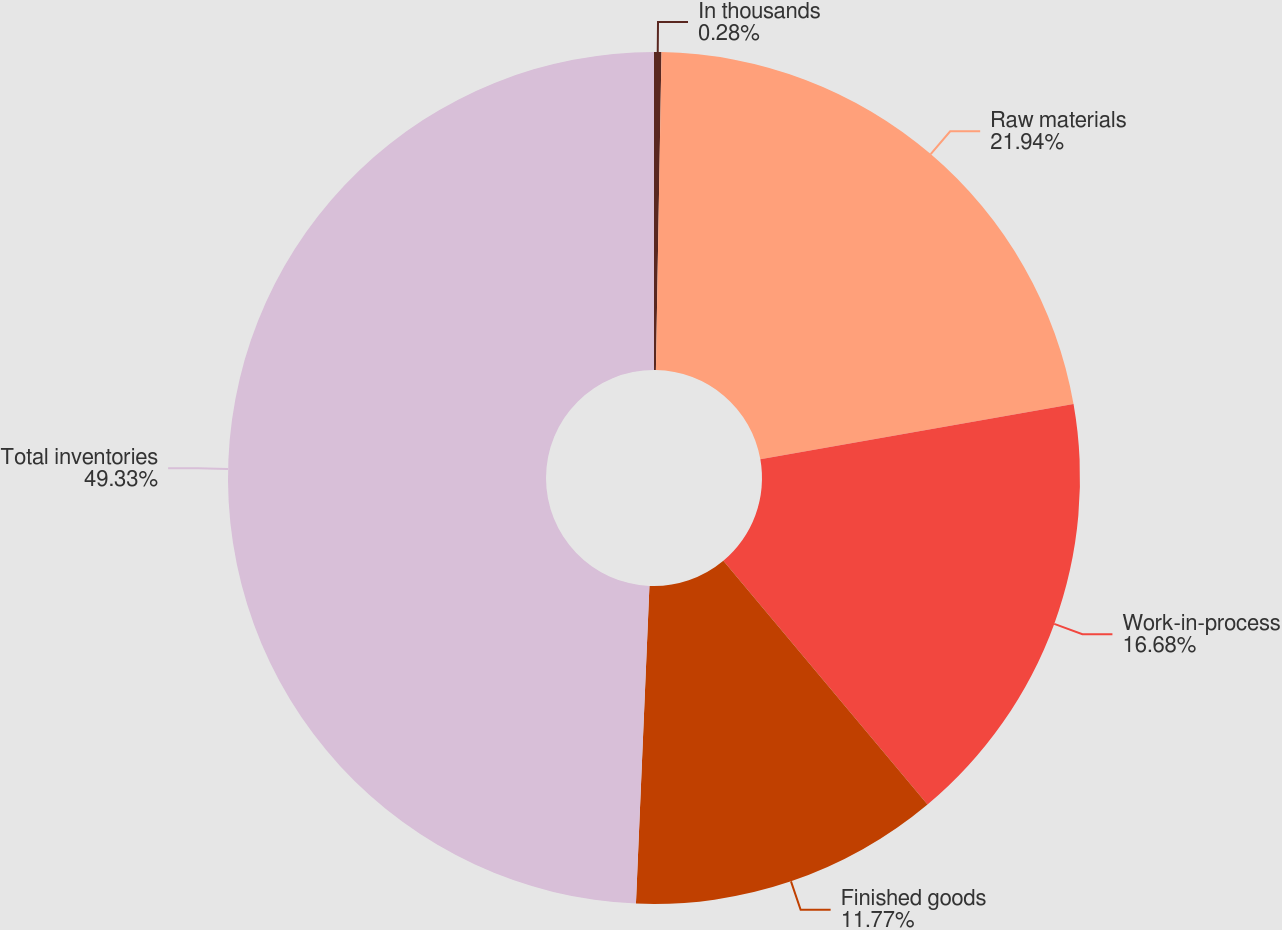Convert chart. <chart><loc_0><loc_0><loc_500><loc_500><pie_chart><fcel>In thousands<fcel>Raw materials<fcel>Work-in-process<fcel>Finished goods<fcel>Total inventories<nl><fcel>0.28%<fcel>21.94%<fcel>16.68%<fcel>11.77%<fcel>49.32%<nl></chart> 